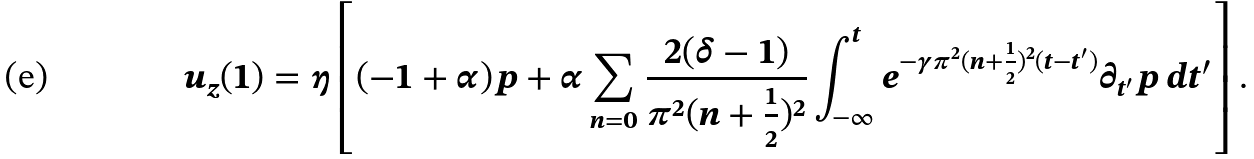<formula> <loc_0><loc_0><loc_500><loc_500>u _ { z } ( 1 ) = \eta \left [ ( - 1 + \alpha ) p + \alpha \sum _ { n = 0 } \frac { 2 ( \delta - 1 ) } { \pi ^ { 2 } ( n + \frac { 1 } { 2 } ) ^ { 2 } } \int _ { - \infty } ^ { t } e ^ { - \gamma \pi ^ { 2 } ( n + \frac { 1 } { 2 } ) ^ { 2 } ( t - t ^ { \prime } ) } \partial _ { t ^ { \prime } } p \, d t ^ { \prime } \right ] .</formula> 